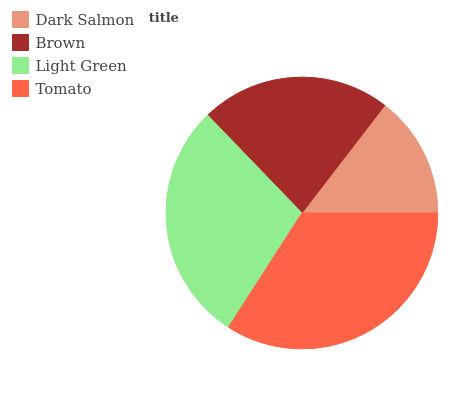Is Dark Salmon the minimum?
Answer yes or no. Yes. Is Tomato the maximum?
Answer yes or no. Yes. Is Brown the minimum?
Answer yes or no. No. Is Brown the maximum?
Answer yes or no. No. Is Brown greater than Dark Salmon?
Answer yes or no. Yes. Is Dark Salmon less than Brown?
Answer yes or no. Yes. Is Dark Salmon greater than Brown?
Answer yes or no. No. Is Brown less than Dark Salmon?
Answer yes or no. No. Is Light Green the high median?
Answer yes or no. Yes. Is Brown the low median?
Answer yes or no. Yes. Is Dark Salmon the high median?
Answer yes or no. No. Is Dark Salmon the low median?
Answer yes or no. No. 